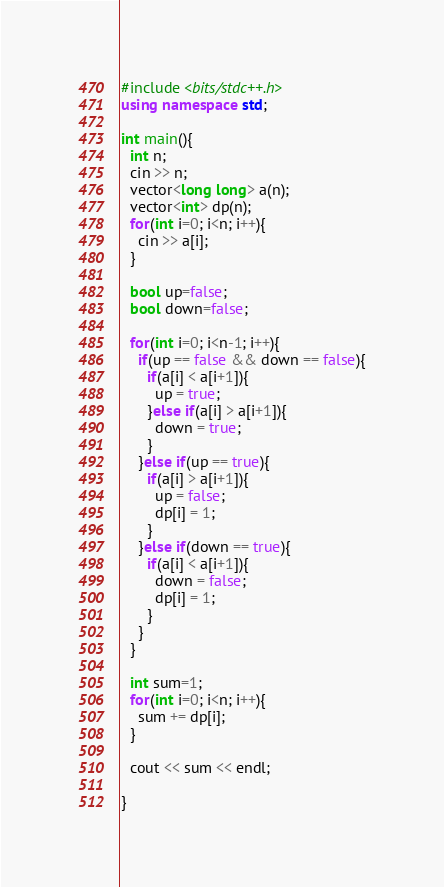<code> <loc_0><loc_0><loc_500><loc_500><_C++_>#include <bits/stdc++.h>
using namespace std;

int main(){
  int n;
  cin >> n;
  vector<long long> a(n);
  vector<int> dp(n);
  for(int i=0; i<n; i++){
    cin >> a[i];
  }
  
  bool up=false;
  bool down=false;
  
  for(int i=0; i<n-1; i++){
    if(up == false && down == false){
      if(a[i] < a[i+1]){
        up = true;
      }else if(a[i] > a[i+1]){
        down = true;
      }
    }else if(up == true){
      if(a[i] > a[i+1]){
        up = false;
        dp[i] = 1;
      }
    }else if(down == true){
      if(a[i] < a[i+1]){
        down = false;
        dp[i] = 1;
      }
    }
  }
    
  int sum=1;
  for(int i=0; i<n; i++){
    sum += dp[i];
  }
  
  cout << sum << endl;
  
}</code> 